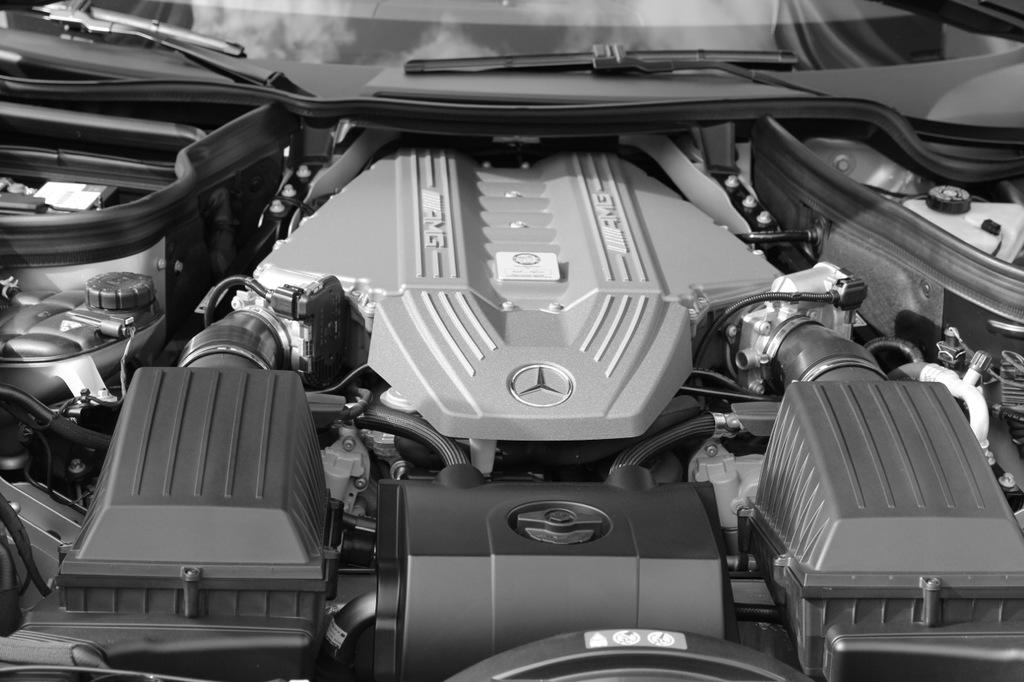What is the main subject of the image? The main subject of the image is a car. What else can be seen in the image besides the car? The image shows car parts. Can you tell if the image was taken during the day or night? The image was likely taken during the day. Where might the car be located in the image? The car may be on the road. What is the rate of recovery for patients in the hospital shown in the image? There is no hospital or patients present in the image; it features a car and car parts. 